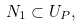Convert formula to latex. <formula><loc_0><loc_0><loc_500><loc_500>N _ { 1 } \subset U _ { P } ,</formula> 